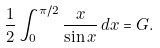Convert formula to latex. <formula><loc_0><loc_0><loc_500><loc_500>\frac { 1 } { 2 } \int _ { 0 } ^ { \pi / 2 } \frac { x } { \sin { x } } \, d x = G .</formula> 